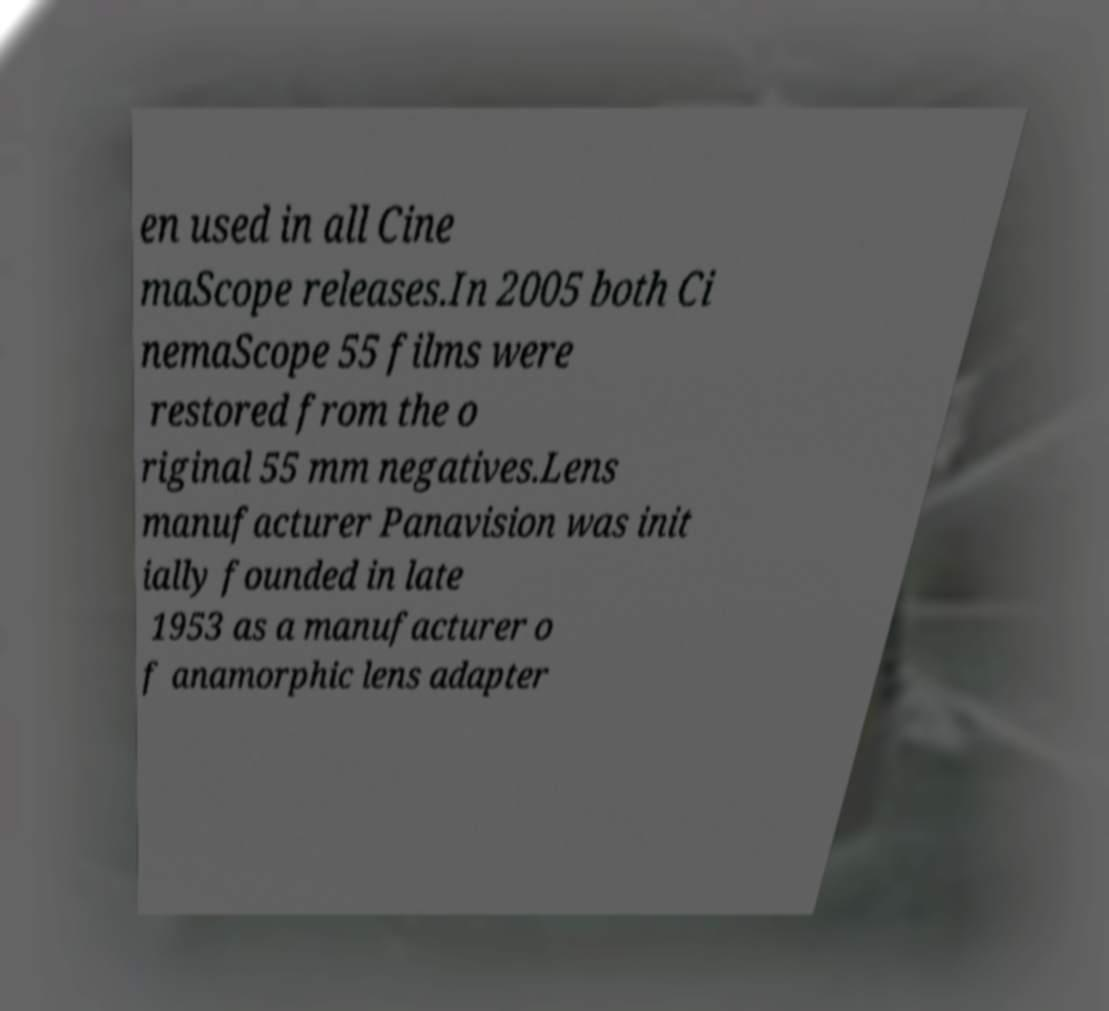I need the written content from this picture converted into text. Can you do that? en used in all Cine maScope releases.In 2005 both Ci nemaScope 55 films were restored from the o riginal 55 mm negatives.Lens manufacturer Panavision was init ially founded in late 1953 as a manufacturer o f anamorphic lens adapter 